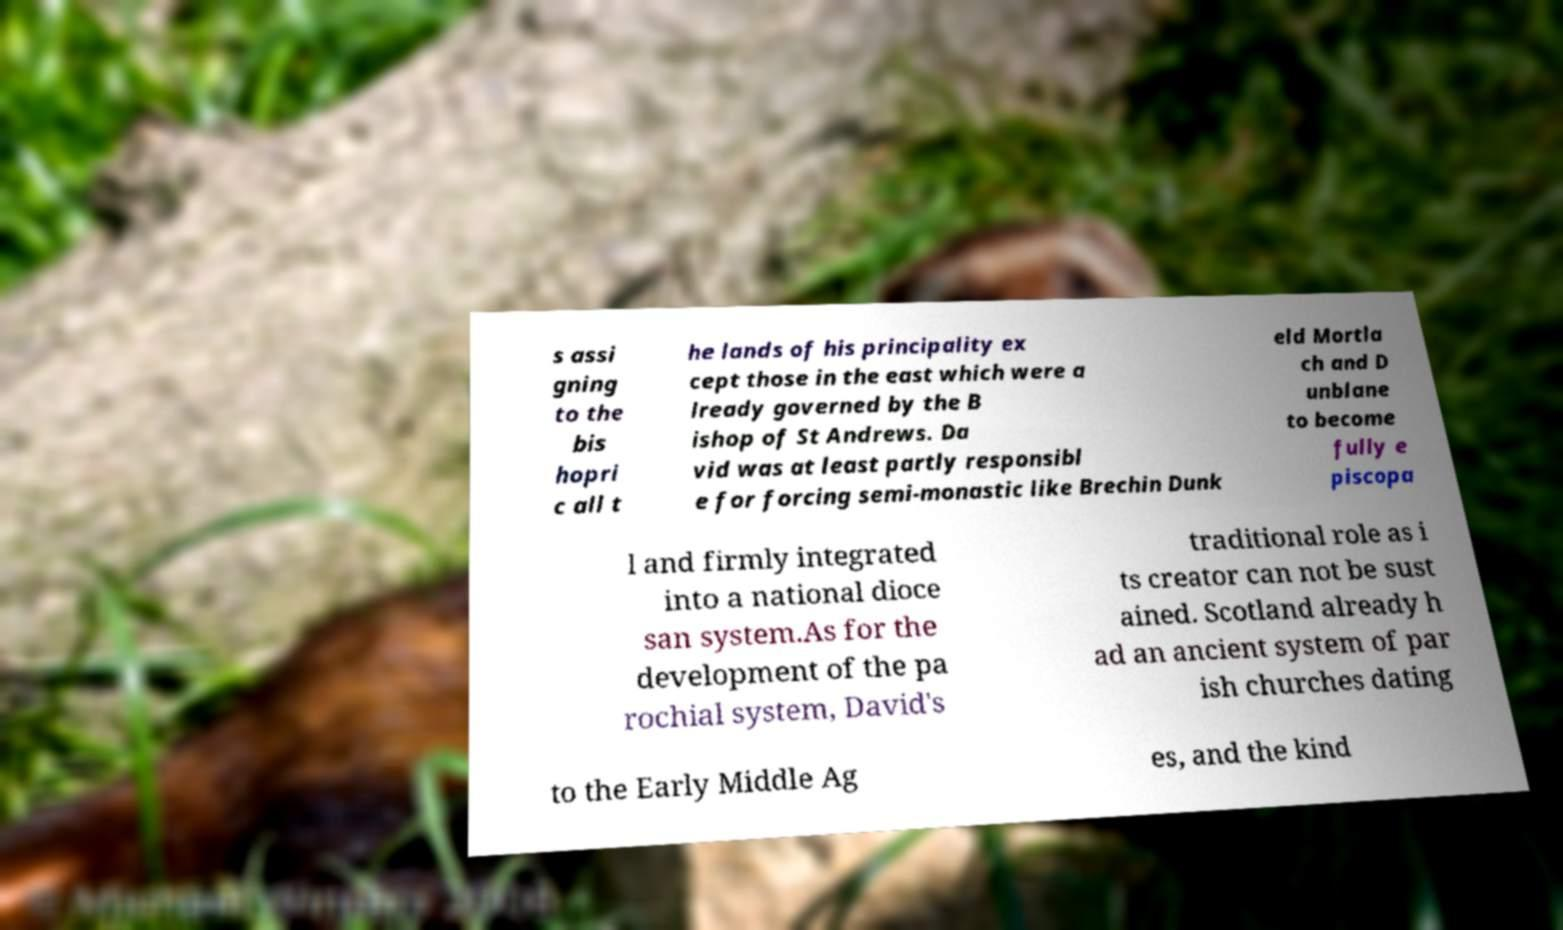Could you extract and type out the text from this image? s assi gning to the bis hopri c all t he lands of his principality ex cept those in the east which were a lready governed by the B ishop of St Andrews. Da vid was at least partly responsibl e for forcing semi-monastic like Brechin Dunk eld Mortla ch and D unblane to become fully e piscopa l and firmly integrated into a national dioce san system.As for the development of the pa rochial system, David's traditional role as i ts creator can not be sust ained. Scotland already h ad an ancient system of par ish churches dating to the Early Middle Ag es, and the kind 